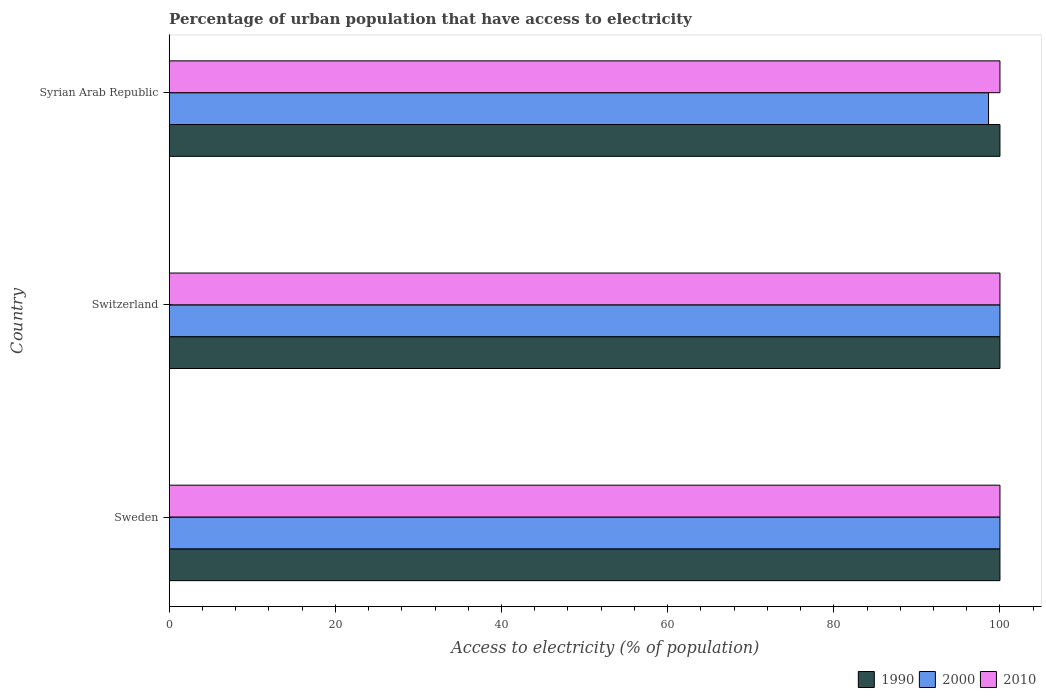How many bars are there on the 3rd tick from the top?
Offer a terse response. 3. How many bars are there on the 3rd tick from the bottom?
Your answer should be very brief. 3. What is the label of the 2nd group of bars from the top?
Your answer should be very brief. Switzerland. What is the percentage of urban population that have access to electricity in 2010 in Sweden?
Ensure brevity in your answer.  100. In which country was the percentage of urban population that have access to electricity in 2010 maximum?
Your answer should be very brief. Sweden. What is the total percentage of urban population that have access to electricity in 1990 in the graph?
Provide a short and direct response. 300. What is the average percentage of urban population that have access to electricity in 2000 per country?
Provide a short and direct response. 99.54. Is the percentage of urban population that have access to electricity in 2000 in Switzerland less than that in Syrian Arab Republic?
Offer a very short reply. No. What is the difference between the highest and the second highest percentage of urban population that have access to electricity in 1990?
Ensure brevity in your answer.  0. What is the difference between the highest and the lowest percentage of urban population that have access to electricity in 1990?
Offer a terse response. 0. In how many countries, is the percentage of urban population that have access to electricity in 1990 greater than the average percentage of urban population that have access to electricity in 1990 taken over all countries?
Ensure brevity in your answer.  0. What does the 2nd bar from the top in Switzerland represents?
Keep it short and to the point. 2000. What does the 2nd bar from the bottom in Syrian Arab Republic represents?
Offer a terse response. 2000. Are the values on the major ticks of X-axis written in scientific E-notation?
Offer a terse response. No. Does the graph contain any zero values?
Keep it short and to the point. No. Does the graph contain grids?
Provide a short and direct response. No. Where does the legend appear in the graph?
Your response must be concise. Bottom right. How many legend labels are there?
Your answer should be very brief. 3. What is the title of the graph?
Your response must be concise. Percentage of urban population that have access to electricity. What is the label or title of the X-axis?
Offer a very short reply. Access to electricity (% of population). What is the label or title of the Y-axis?
Make the answer very short. Country. What is the Access to electricity (% of population) in 1990 in Sweden?
Your answer should be compact. 100. What is the Access to electricity (% of population) of 2010 in Sweden?
Your answer should be compact. 100. What is the Access to electricity (% of population) of 1990 in Switzerland?
Keep it short and to the point. 100. What is the Access to electricity (% of population) in 2000 in Switzerland?
Provide a succinct answer. 100. What is the Access to electricity (% of population) of 1990 in Syrian Arab Republic?
Your response must be concise. 100. What is the Access to electricity (% of population) in 2000 in Syrian Arab Republic?
Offer a very short reply. 98.63. What is the Access to electricity (% of population) in 2010 in Syrian Arab Republic?
Your answer should be compact. 100. Across all countries, what is the maximum Access to electricity (% of population) in 1990?
Keep it short and to the point. 100. Across all countries, what is the maximum Access to electricity (% of population) in 2000?
Provide a short and direct response. 100. Across all countries, what is the minimum Access to electricity (% of population) of 2000?
Your answer should be compact. 98.63. Across all countries, what is the minimum Access to electricity (% of population) of 2010?
Offer a terse response. 100. What is the total Access to electricity (% of population) in 1990 in the graph?
Your answer should be compact. 300. What is the total Access to electricity (% of population) of 2000 in the graph?
Ensure brevity in your answer.  298.63. What is the total Access to electricity (% of population) in 2010 in the graph?
Your answer should be compact. 300. What is the difference between the Access to electricity (% of population) of 2010 in Sweden and that in Switzerland?
Your response must be concise. 0. What is the difference between the Access to electricity (% of population) of 1990 in Sweden and that in Syrian Arab Republic?
Your answer should be compact. 0. What is the difference between the Access to electricity (% of population) of 2000 in Sweden and that in Syrian Arab Republic?
Offer a terse response. 1.37. What is the difference between the Access to electricity (% of population) in 2000 in Switzerland and that in Syrian Arab Republic?
Offer a terse response. 1.37. What is the difference between the Access to electricity (% of population) of 1990 in Sweden and the Access to electricity (% of population) of 2000 in Switzerland?
Your answer should be compact. 0. What is the difference between the Access to electricity (% of population) of 1990 in Sweden and the Access to electricity (% of population) of 2010 in Switzerland?
Your response must be concise. 0. What is the difference between the Access to electricity (% of population) in 1990 in Sweden and the Access to electricity (% of population) in 2000 in Syrian Arab Republic?
Give a very brief answer. 1.37. What is the difference between the Access to electricity (% of population) in 1990 in Switzerland and the Access to electricity (% of population) in 2000 in Syrian Arab Republic?
Make the answer very short. 1.37. What is the difference between the Access to electricity (% of population) of 2000 in Switzerland and the Access to electricity (% of population) of 2010 in Syrian Arab Republic?
Offer a terse response. 0. What is the average Access to electricity (% of population) in 1990 per country?
Provide a succinct answer. 100. What is the average Access to electricity (% of population) in 2000 per country?
Your answer should be compact. 99.54. What is the difference between the Access to electricity (% of population) in 1990 and Access to electricity (% of population) in 2010 in Sweden?
Offer a terse response. 0. What is the difference between the Access to electricity (% of population) of 1990 and Access to electricity (% of population) of 2000 in Switzerland?
Provide a short and direct response. 0. What is the difference between the Access to electricity (% of population) in 1990 and Access to electricity (% of population) in 2010 in Switzerland?
Offer a very short reply. 0. What is the difference between the Access to electricity (% of population) in 1990 and Access to electricity (% of population) in 2000 in Syrian Arab Republic?
Your answer should be very brief. 1.37. What is the difference between the Access to electricity (% of population) of 1990 and Access to electricity (% of population) of 2010 in Syrian Arab Republic?
Offer a very short reply. 0. What is the difference between the Access to electricity (% of population) of 2000 and Access to electricity (% of population) of 2010 in Syrian Arab Republic?
Give a very brief answer. -1.37. What is the ratio of the Access to electricity (% of population) in 1990 in Sweden to that in Syrian Arab Republic?
Provide a succinct answer. 1. What is the ratio of the Access to electricity (% of population) of 2000 in Sweden to that in Syrian Arab Republic?
Offer a very short reply. 1.01. What is the ratio of the Access to electricity (% of population) in 2010 in Sweden to that in Syrian Arab Republic?
Keep it short and to the point. 1. What is the ratio of the Access to electricity (% of population) in 2000 in Switzerland to that in Syrian Arab Republic?
Offer a terse response. 1.01. What is the ratio of the Access to electricity (% of population) of 2010 in Switzerland to that in Syrian Arab Republic?
Offer a very short reply. 1. What is the difference between the highest and the second highest Access to electricity (% of population) of 1990?
Keep it short and to the point. 0. What is the difference between the highest and the second highest Access to electricity (% of population) of 2000?
Your answer should be very brief. 0. What is the difference between the highest and the lowest Access to electricity (% of population) in 2000?
Keep it short and to the point. 1.37. 